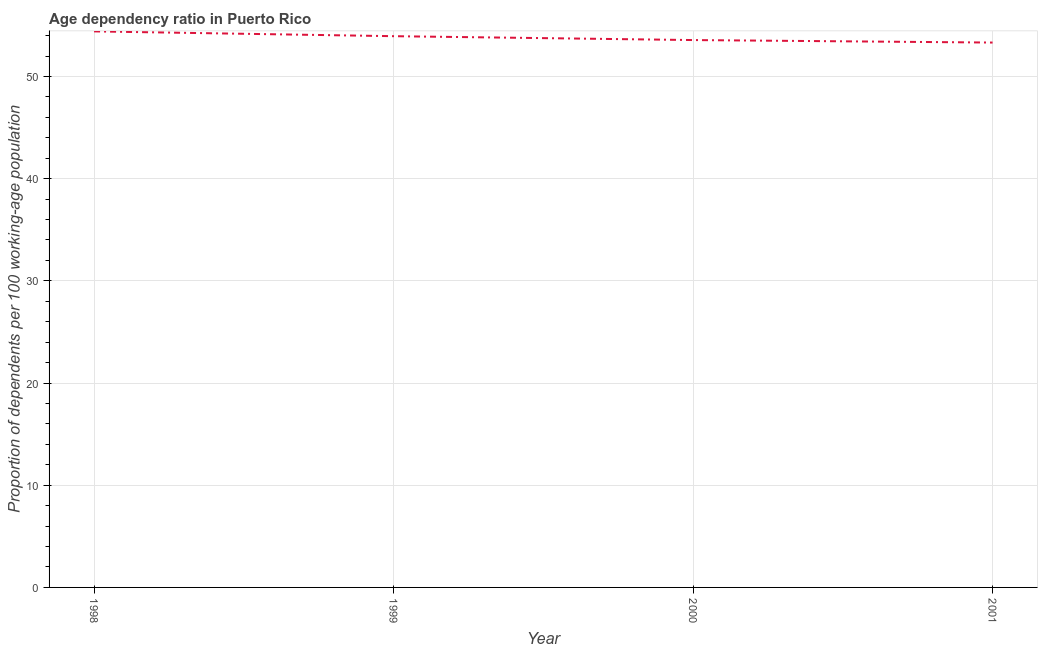What is the age dependency ratio in 2000?
Your answer should be very brief. 53.56. Across all years, what is the maximum age dependency ratio?
Make the answer very short. 54.41. Across all years, what is the minimum age dependency ratio?
Provide a short and direct response. 53.32. In which year was the age dependency ratio minimum?
Your response must be concise. 2001. What is the sum of the age dependency ratio?
Provide a succinct answer. 215.22. What is the difference between the age dependency ratio in 2000 and 2001?
Your answer should be compact. 0.24. What is the average age dependency ratio per year?
Ensure brevity in your answer.  53.81. What is the median age dependency ratio?
Offer a terse response. 53.75. In how many years, is the age dependency ratio greater than 16 ?
Keep it short and to the point. 4. Do a majority of the years between 1998 and 2001 (inclusive) have age dependency ratio greater than 14 ?
Offer a terse response. Yes. What is the ratio of the age dependency ratio in 2000 to that in 2001?
Offer a very short reply. 1. What is the difference between the highest and the second highest age dependency ratio?
Your response must be concise. 0.47. Is the sum of the age dependency ratio in 1998 and 2001 greater than the maximum age dependency ratio across all years?
Make the answer very short. Yes. What is the difference between the highest and the lowest age dependency ratio?
Your response must be concise. 1.09. Does the graph contain any zero values?
Provide a succinct answer. No. Does the graph contain grids?
Make the answer very short. Yes. What is the title of the graph?
Ensure brevity in your answer.  Age dependency ratio in Puerto Rico. What is the label or title of the X-axis?
Keep it short and to the point. Year. What is the label or title of the Y-axis?
Provide a short and direct response. Proportion of dependents per 100 working-age population. What is the Proportion of dependents per 100 working-age population in 1998?
Provide a succinct answer. 54.41. What is the Proportion of dependents per 100 working-age population in 1999?
Make the answer very short. 53.94. What is the Proportion of dependents per 100 working-age population of 2000?
Your response must be concise. 53.56. What is the Proportion of dependents per 100 working-age population of 2001?
Provide a short and direct response. 53.32. What is the difference between the Proportion of dependents per 100 working-age population in 1998 and 1999?
Provide a succinct answer. 0.47. What is the difference between the Proportion of dependents per 100 working-age population in 1998 and 2000?
Provide a succinct answer. 0.85. What is the difference between the Proportion of dependents per 100 working-age population in 1998 and 2001?
Make the answer very short. 1.09. What is the difference between the Proportion of dependents per 100 working-age population in 1999 and 2000?
Your answer should be compact. 0.38. What is the difference between the Proportion of dependents per 100 working-age population in 1999 and 2001?
Offer a terse response. 0.62. What is the difference between the Proportion of dependents per 100 working-age population in 2000 and 2001?
Ensure brevity in your answer.  0.24. What is the ratio of the Proportion of dependents per 100 working-age population in 1998 to that in 1999?
Ensure brevity in your answer.  1.01. What is the ratio of the Proportion of dependents per 100 working-age population in 1999 to that in 2000?
Your response must be concise. 1.01. 